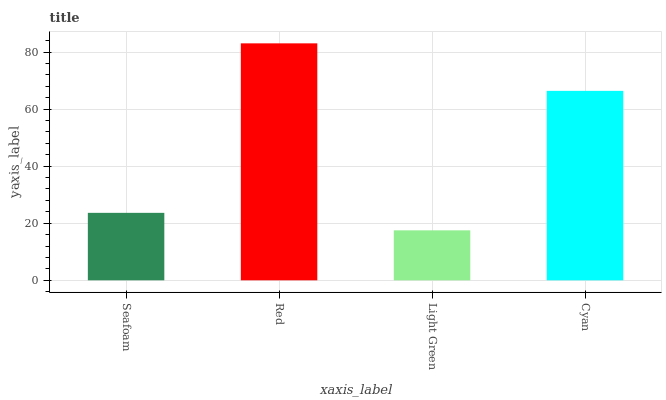Is Light Green the minimum?
Answer yes or no. Yes. Is Red the maximum?
Answer yes or no. Yes. Is Red the minimum?
Answer yes or no. No. Is Light Green the maximum?
Answer yes or no. No. Is Red greater than Light Green?
Answer yes or no. Yes. Is Light Green less than Red?
Answer yes or no. Yes. Is Light Green greater than Red?
Answer yes or no. No. Is Red less than Light Green?
Answer yes or no. No. Is Cyan the high median?
Answer yes or no. Yes. Is Seafoam the low median?
Answer yes or no. Yes. Is Light Green the high median?
Answer yes or no. No. Is Cyan the low median?
Answer yes or no. No. 